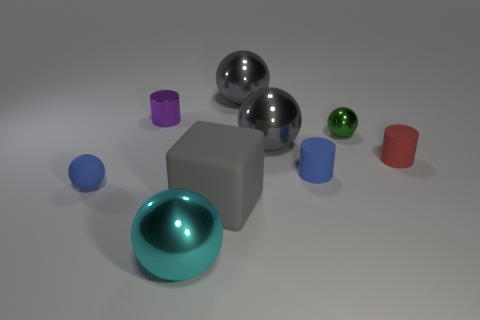There is a small blue rubber thing that is on the right side of the blue ball; are there any small purple cylinders to the right of it?
Make the answer very short. No. There is a big block; how many metallic balls are behind it?
Your response must be concise. 3. There is a small matte object that is the same shape as the small green shiny thing; what color is it?
Your answer should be compact. Blue. Are the small object that is to the right of the tiny green ball and the tiny ball on the right side of the small purple object made of the same material?
Give a very brief answer. No. Is the color of the rubber ball the same as the tiny rubber cylinder that is to the left of the red rubber cylinder?
Make the answer very short. Yes. There is a tiny object that is behind the small red cylinder and on the right side of the purple cylinder; what shape is it?
Your answer should be compact. Sphere. How many large cyan metallic balls are there?
Offer a terse response. 1. There is a thing that is the same color as the rubber sphere; what is its shape?
Make the answer very short. Cylinder. What size is the blue rubber object that is the same shape as the big cyan object?
Offer a very short reply. Small. There is a big gray object in front of the tiny blue matte cylinder; is its shape the same as the small green shiny thing?
Make the answer very short. No. 